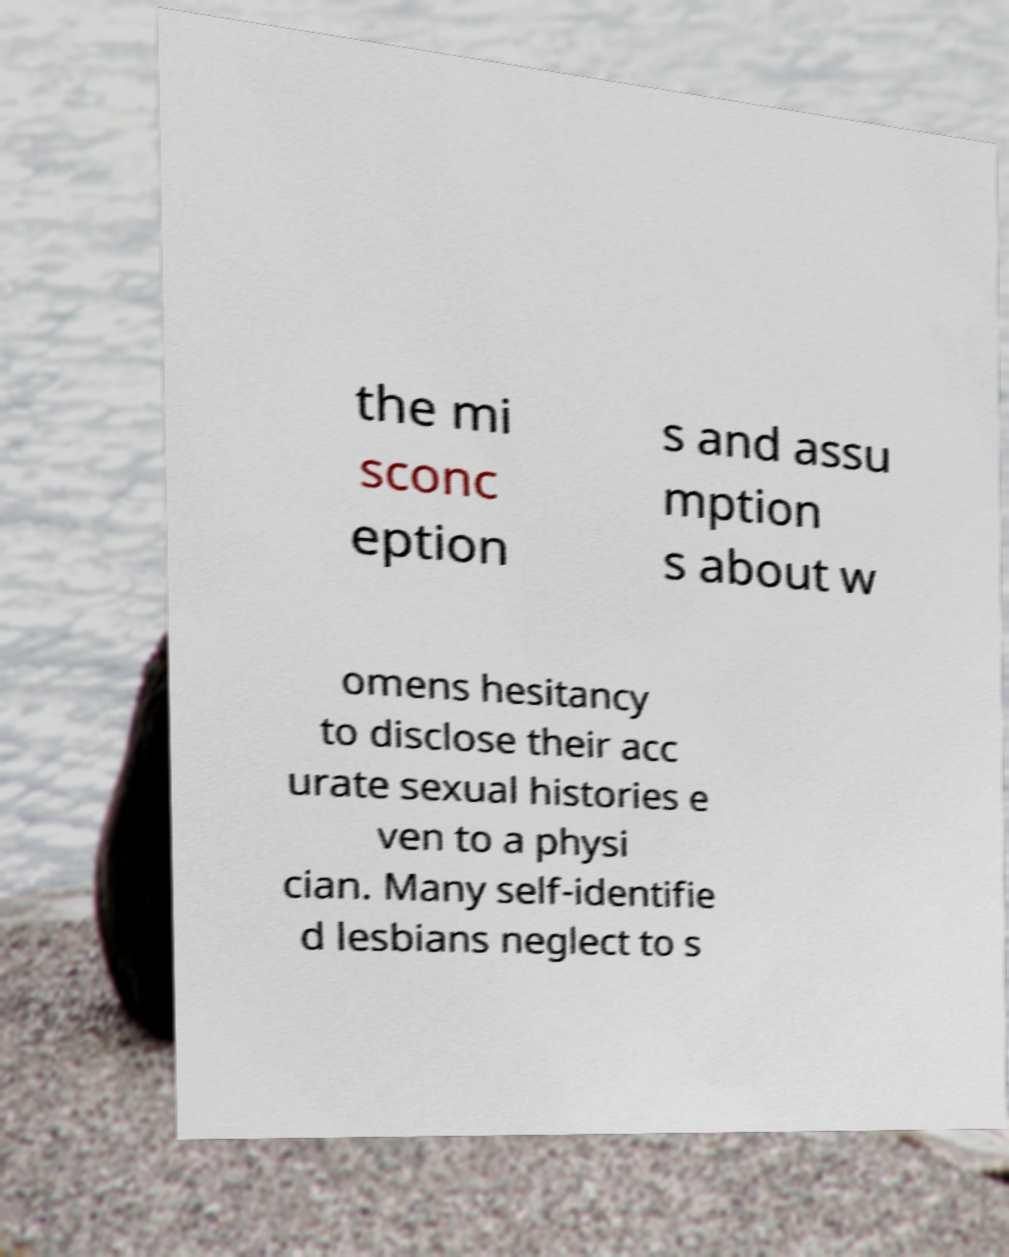Can you read and provide the text displayed in the image?This photo seems to have some interesting text. Can you extract and type it out for me? the mi sconc eption s and assu mption s about w omens hesitancy to disclose their acc urate sexual histories e ven to a physi cian. Many self-identifie d lesbians neglect to s 